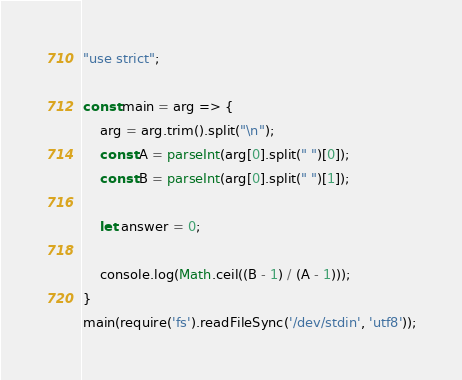Convert code to text. <code><loc_0><loc_0><loc_500><loc_500><_JavaScript_>"use strict";
    
const main = arg => {
    arg = arg.trim().split("\n");
    const A = parseInt(arg[0].split(" ")[0]);
    const B = parseInt(arg[0].split(" ")[1]);
    
    let answer = 0;
    
    console.log(Math.ceil((B - 1) / (A - 1)));
}
main(require('fs').readFileSync('/dev/stdin', 'utf8'));</code> 